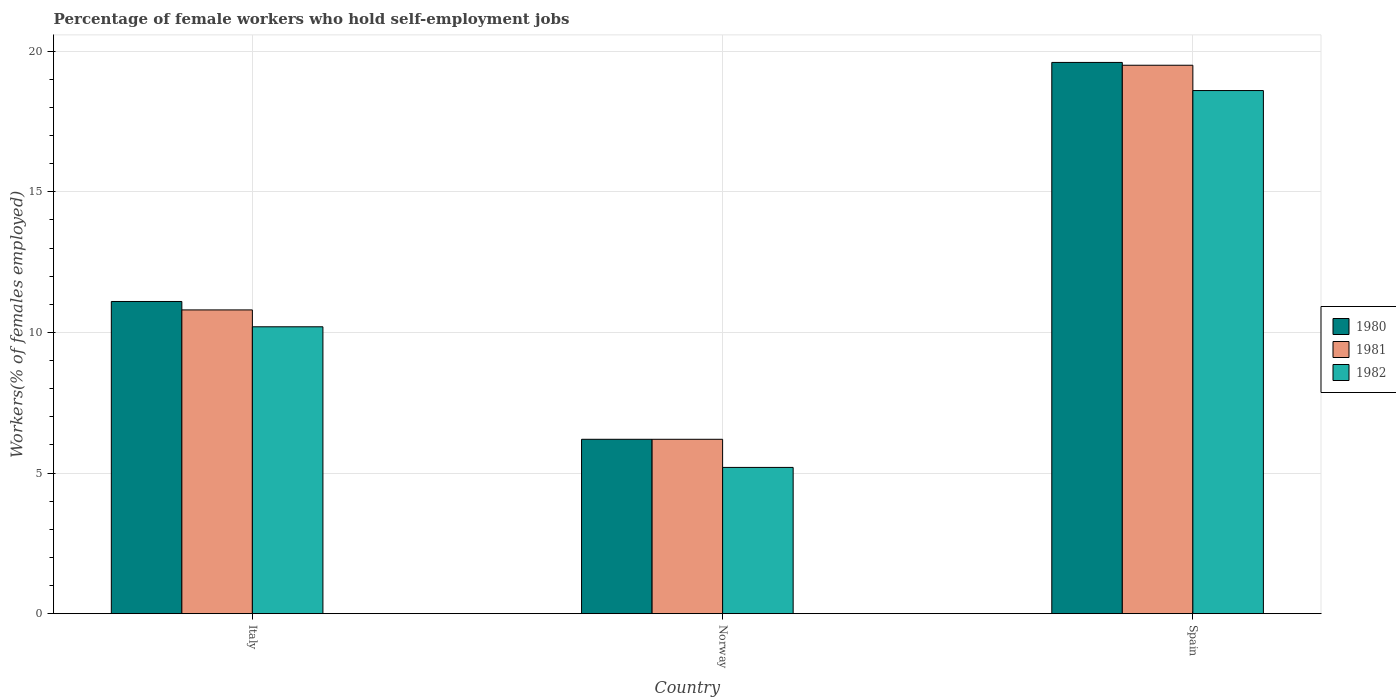Are the number of bars per tick equal to the number of legend labels?
Offer a terse response. Yes. How many bars are there on the 2nd tick from the left?
Your response must be concise. 3. What is the label of the 2nd group of bars from the left?
Ensure brevity in your answer.  Norway. What is the percentage of self-employed female workers in 1981 in Spain?
Make the answer very short. 19.5. Across all countries, what is the maximum percentage of self-employed female workers in 1980?
Give a very brief answer. 19.6. Across all countries, what is the minimum percentage of self-employed female workers in 1980?
Keep it short and to the point. 6.2. In which country was the percentage of self-employed female workers in 1980 maximum?
Offer a terse response. Spain. What is the total percentage of self-employed female workers in 1982 in the graph?
Ensure brevity in your answer.  34. What is the difference between the percentage of self-employed female workers in 1981 in Norway and that in Spain?
Make the answer very short. -13.3. What is the difference between the percentage of self-employed female workers in 1980 in Spain and the percentage of self-employed female workers in 1981 in Italy?
Provide a short and direct response. 8.8. What is the average percentage of self-employed female workers in 1981 per country?
Your response must be concise. 12.17. What is the difference between the percentage of self-employed female workers of/in 1980 and percentage of self-employed female workers of/in 1982 in Spain?
Offer a very short reply. 1. In how many countries, is the percentage of self-employed female workers in 1982 greater than 4 %?
Offer a very short reply. 3. What is the ratio of the percentage of self-employed female workers in 1981 in Italy to that in Spain?
Provide a succinct answer. 0.55. What is the difference between the highest and the second highest percentage of self-employed female workers in 1982?
Provide a succinct answer. 8.4. What is the difference between the highest and the lowest percentage of self-employed female workers in 1982?
Ensure brevity in your answer.  13.4. What does the 3rd bar from the right in Norway represents?
Give a very brief answer. 1980. Are all the bars in the graph horizontal?
Your answer should be very brief. No. How many countries are there in the graph?
Your answer should be very brief. 3. What is the difference between two consecutive major ticks on the Y-axis?
Your response must be concise. 5. Does the graph contain any zero values?
Your response must be concise. No. How many legend labels are there?
Ensure brevity in your answer.  3. How are the legend labels stacked?
Keep it short and to the point. Vertical. What is the title of the graph?
Provide a short and direct response. Percentage of female workers who hold self-employment jobs. What is the label or title of the X-axis?
Keep it short and to the point. Country. What is the label or title of the Y-axis?
Your response must be concise. Workers(% of females employed). What is the Workers(% of females employed) in 1980 in Italy?
Offer a very short reply. 11.1. What is the Workers(% of females employed) of 1981 in Italy?
Ensure brevity in your answer.  10.8. What is the Workers(% of females employed) of 1982 in Italy?
Provide a succinct answer. 10.2. What is the Workers(% of females employed) in 1980 in Norway?
Give a very brief answer. 6.2. What is the Workers(% of females employed) in 1981 in Norway?
Provide a succinct answer. 6.2. What is the Workers(% of females employed) in 1982 in Norway?
Provide a succinct answer. 5.2. What is the Workers(% of females employed) in 1980 in Spain?
Ensure brevity in your answer.  19.6. What is the Workers(% of females employed) in 1982 in Spain?
Keep it short and to the point. 18.6. Across all countries, what is the maximum Workers(% of females employed) in 1980?
Offer a terse response. 19.6. Across all countries, what is the maximum Workers(% of females employed) in 1982?
Your response must be concise. 18.6. Across all countries, what is the minimum Workers(% of females employed) of 1980?
Make the answer very short. 6.2. Across all countries, what is the minimum Workers(% of females employed) of 1981?
Give a very brief answer. 6.2. Across all countries, what is the minimum Workers(% of females employed) in 1982?
Offer a very short reply. 5.2. What is the total Workers(% of females employed) of 1980 in the graph?
Ensure brevity in your answer.  36.9. What is the total Workers(% of females employed) in 1981 in the graph?
Ensure brevity in your answer.  36.5. What is the difference between the Workers(% of females employed) in 1980 in Italy and that in Norway?
Your answer should be compact. 4.9. What is the difference between the Workers(% of females employed) in 1981 in Italy and that in Norway?
Make the answer very short. 4.6. What is the difference between the Workers(% of females employed) in 1982 in Italy and that in Norway?
Keep it short and to the point. 5. What is the difference between the Workers(% of females employed) in 1982 in Italy and that in Spain?
Your answer should be very brief. -8.4. What is the difference between the Workers(% of females employed) in 1980 in Norway and that in Spain?
Your answer should be compact. -13.4. What is the difference between the Workers(% of females employed) of 1980 in Italy and the Workers(% of females employed) of 1981 in Norway?
Your response must be concise. 4.9. What is the difference between the Workers(% of females employed) of 1981 in Italy and the Workers(% of females employed) of 1982 in Norway?
Ensure brevity in your answer.  5.6. What is the difference between the Workers(% of females employed) of 1980 in Norway and the Workers(% of females employed) of 1981 in Spain?
Give a very brief answer. -13.3. What is the difference between the Workers(% of females employed) in 1980 in Norway and the Workers(% of females employed) in 1982 in Spain?
Provide a succinct answer. -12.4. What is the difference between the Workers(% of females employed) of 1981 in Norway and the Workers(% of females employed) of 1982 in Spain?
Provide a succinct answer. -12.4. What is the average Workers(% of females employed) of 1981 per country?
Ensure brevity in your answer.  12.17. What is the average Workers(% of females employed) of 1982 per country?
Give a very brief answer. 11.33. What is the difference between the Workers(% of females employed) of 1980 and Workers(% of females employed) of 1982 in Italy?
Your answer should be very brief. 0.9. What is the difference between the Workers(% of females employed) of 1980 and Workers(% of females employed) of 1982 in Norway?
Ensure brevity in your answer.  1. What is the difference between the Workers(% of females employed) in 1980 and Workers(% of females employed) in 1981 in Spain?
Provide a succinct answer. 0.1. What is the ratio of the Workers(% of females employed) of 1980 in Italy to that in Norway?
Ensure brevity in your answer.  1.79. What is the ratio of the Workers(% of females employed) of 1981 in Italy to that in Norway?
Make the answer very short. 1.74. What is the ratio of the Workers(% of females employed) of 1982 in Italy to that in Norway?
Provide a short and direct response. 1.96. What is the ratio of the Workers(% of females employed) in 1980 in Italy to that in Spain?
Give a very brief answer. 0.57. What is the ratio of the Workers(% of females employed) of 1981 in Italy to that in Spain?
Offer a very short reply. 0.55. What is the ratio of the Workers(% of females employed) in 1982 in Italy to that in Spain?
Your response must be concise. 0.55. What is the ratio of the Workers(% of females employed) of 1980 in Norway to that in Spain?
Give a very brief answer. 0.32. What is the ratio of the Workers(% of females employed) of 1981 in Norway to that in Spain?
Offer a terse response. 0.32. What is the ratio of the Workers(% of females employed) in 1982 in Norway to that in Spain?
Provide a short and direct response. 0.28. What is the difference between the highest and the second highest Workers(% of females employed) in 1980?
Make the answer very short. 8.5. What is the difference between the highest and the second highest Workers(% of females employed) in 1981?
Offer a terse response. 8.7. 